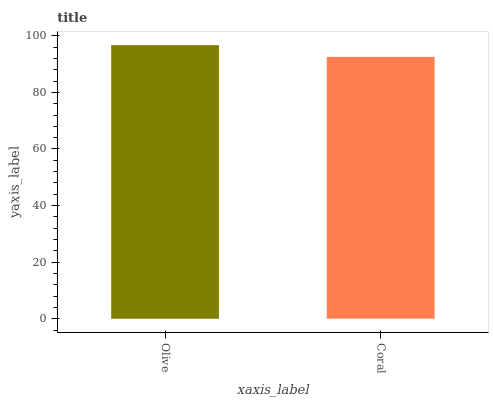Is Coral the minimum?
Answer yes or no. Yes. Is Olive the maximum?
Answer yes or no. Yes. Is Coral the maximum?
Answer yes or no. No. Is Olive greater than Coral?
Answer yes or no. Yes. Is Coral less than Olive?
Answer yes or no. Yes. Is Coral greater than Olive?
Answer yes or no. No. Is Olive less than Coral?
Answer yes or no. No. Is Olive the high median?
Answer yes or no. Yes. Is Coral the low median?
Answer yes or no. Yes. Is Coral the high median?
Answer yes or no. No. Is Olive the low median?
Answer yes or no. No. 